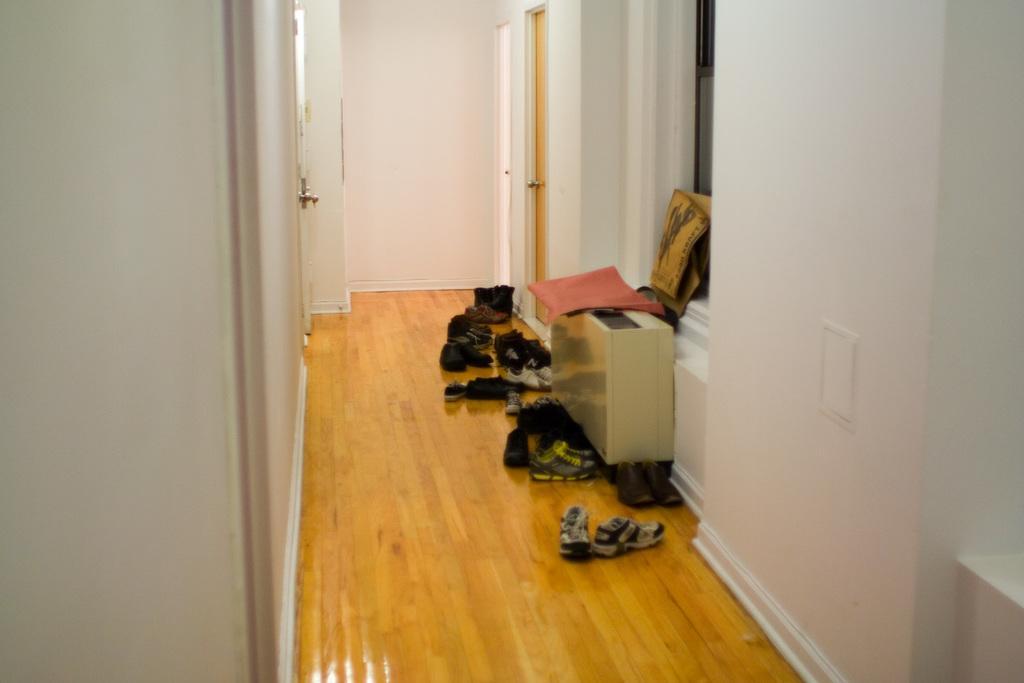Describe this image in one or two sentences. In this image I can see doors, window, wall and pairs of shoes in a hall. This image is taken may be in a house. 